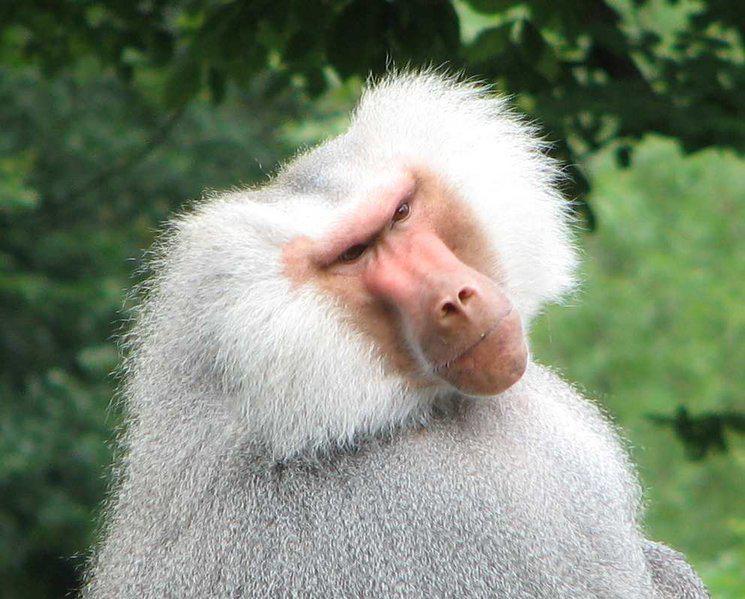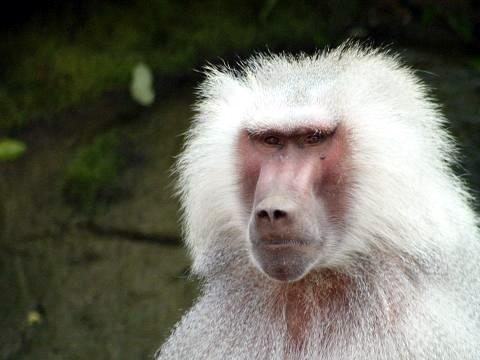The first image is the image on the left, the second image is the image on the right. Assess this claim about the two images: "The left image is of a single animal with its mouth open.". Correct or not? Answer yes or no. No. 